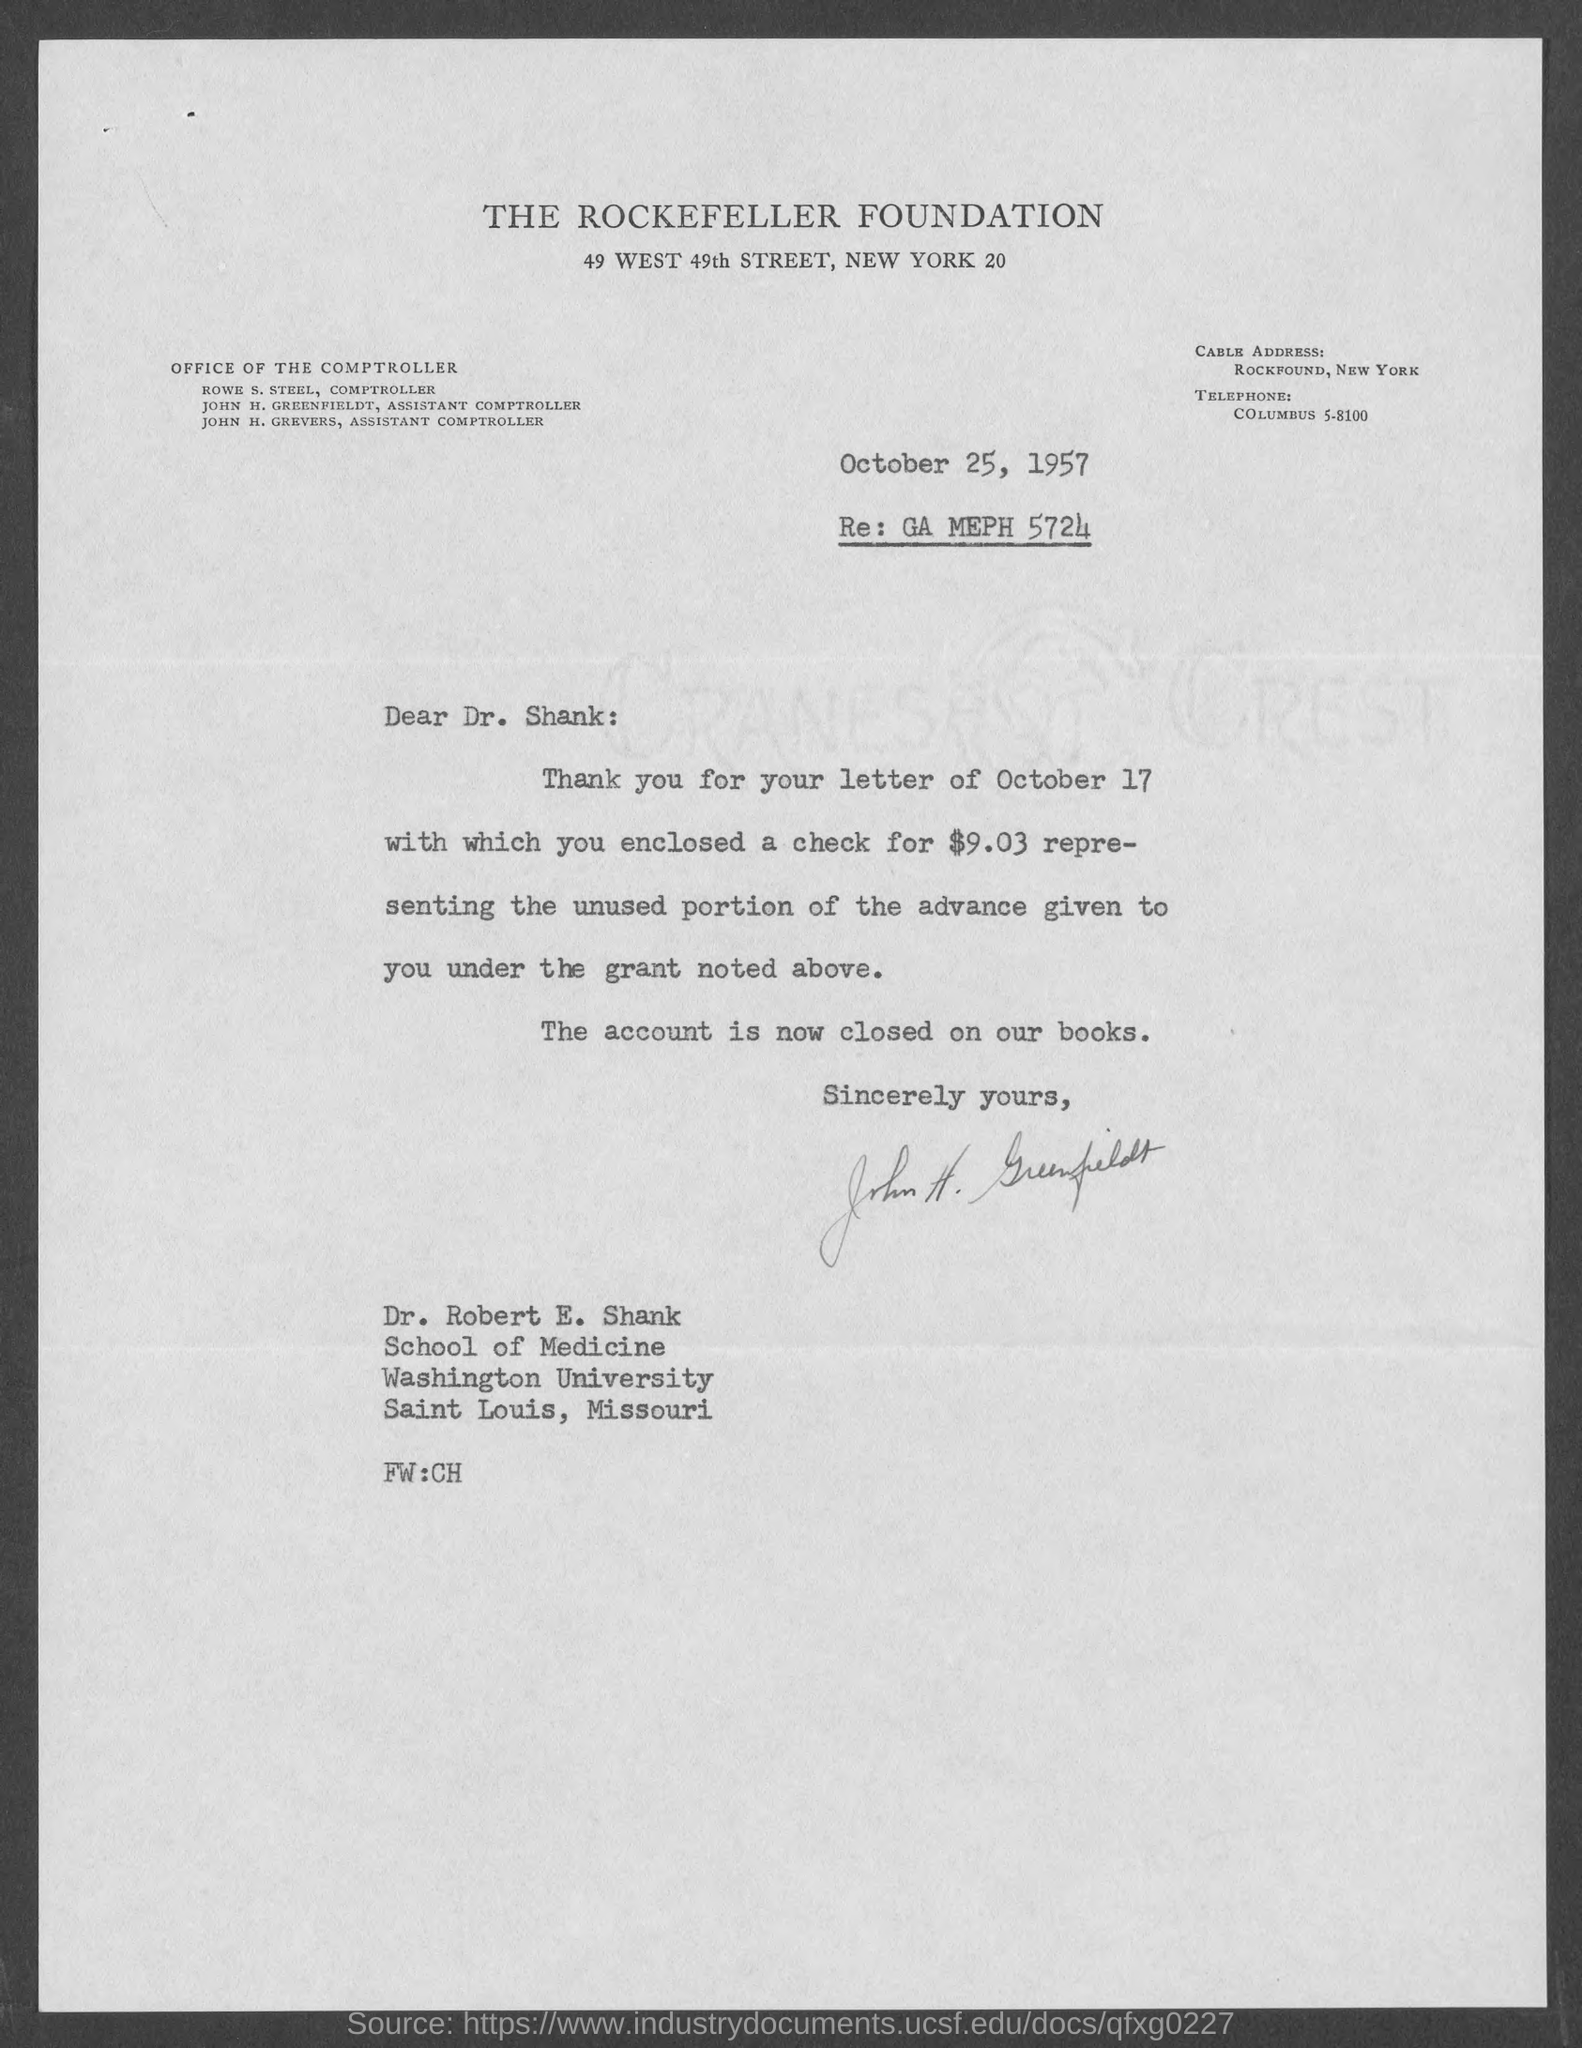Give some essential details in this illustration. The date mentioned at the top of the document is October 25, 1957. 